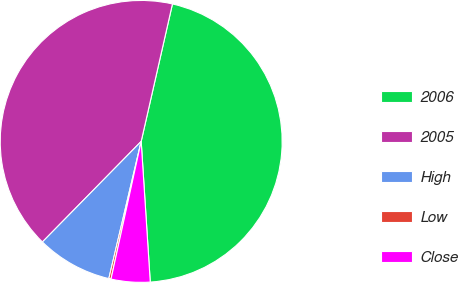<chart> <loc_0><loc_0><loc_500><loc_500><pie_chart><fcel>2006<fcel>2005<fcel>High<fcel>Low<fcel>Close<nl><fcel>45.41%<fcel>41.2%<fcel>8.67%<fcel>0.25%<fcel>4.46%<nl></chart> 